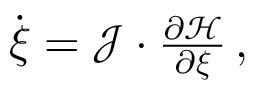Convert formula to latex. <formula><loc_0><loc_0><loc_500><loc_500>\begin{array} { r } { \dot { \xi } = { \mathcal { J } } \cdot \frac { \partial { \mathcal { H } } } { \partial \xi } \, , } \end{array}</formula> 